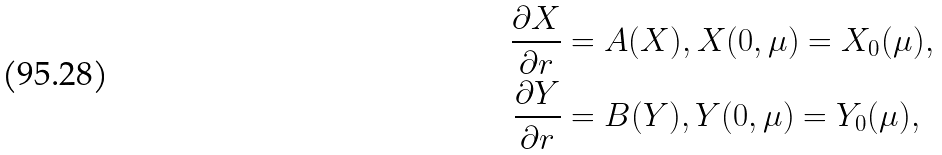<formula> <loc_0><loc_0><loc_500><loc_500>\frac { \partial X } { \partial r } & = A ( X ) , X ( 0 , \mu ) = X _ { 0 } ( \mu ) , \\ \frac { \partial Y } { \partial r } & = B ( Y ) , Y ( 0 , \mu ) = Y _ { 0 } ( \mu ) ,</formula> 